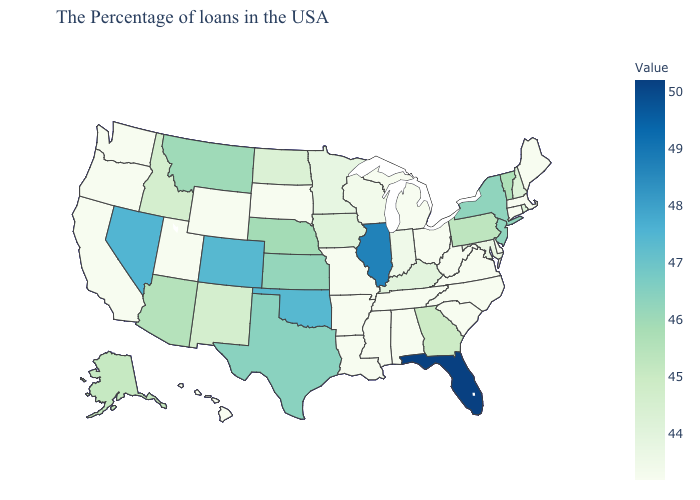Does Florida have the lowest value in the South?
Give a very brief answer. No. Which states have the lowest value in the West?
Write a very short answer. Wyoming, Utah, California, Washington, Oregon, Hawaii. Among the states that border Oklahoma , does Missouri have the highest value?
Keep it brief. No. Does the map have missing data?
Short answer required. No. Among the states that border Pennsylvania , does New York have the highest value?
Concise answer only. Yes. Among the states that border Nevada , which have the highest value?
Write a very short answer. Arizona. Among the states that border Illinois , which have the lowest value?
Write a very short answer. Missouri. 